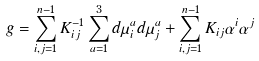<formula> <loc_0><loc_0><loc_500><loc_500>g = \sum _ { i , j = 1 } ^ { n - 1 } K _ { i j } ^ { - 1 } \sum _ { a = 1 } ^ { 3 } d \mu _ { i } ^ { a } d \mu _ { j } ^ { a } + \sum _ { i , j = 1 } ^ { n - 1 } K _ { i j } \alpha ^ { i } \alpha ^ { j }</formula> 